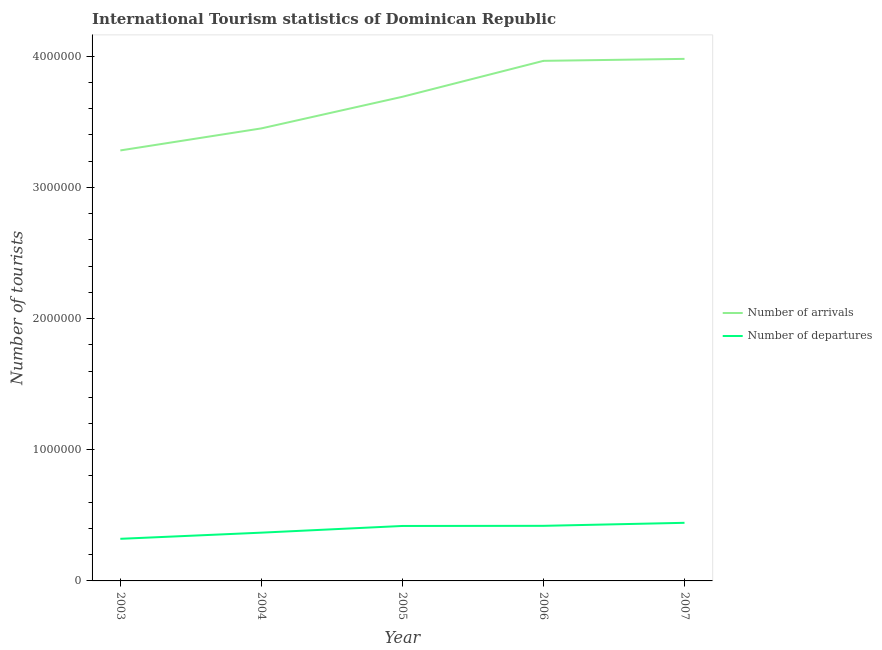How many different coloured lines are there?
Give a very brief answer. 2. Does the line corresponding to number of tourist departures intersect with the line corresponding to number of tourist arrivals?
Offer a very short reply. No. What is the number of tourist arrivals in 2007?
Your answer should be very brief. 3.98e+06. Across all years, what is the maximum number of tourist departures?
Give a very brief answer. 4.43e+05. Across all years, what is the minimum number of tourist arrivals?
Provide a succinct answer. 3.28e+06. In which year was the number of tourist arrivals maximum?
Provide a short and direct response. 2007. What is the total number of tourist departures in the graph?
Your response must be concise. 1.97e+06. What is the difference between the number of tourist departures in 2004 and that in 2007?
Give a very brief answer. -7.50e+04. What is the difference between the number of tourist departures in 2003 and the number of tourist arrivals in 2004?
Provide a succinct answer. -3.13e+06. What is the average number of tourist departures per year?
Ensure brevity in your answer.  3.94e+05. In the year 2007, what is the difference between the number of tourist departures and number of tourist arrivals?
Offer a very short reply. -3.54e+06. What is the ratio of the number of tourist departures in 2003 to that in 2004?
Ensure brevity in your answer.  0.87. Is the number of tourist arrivals in 2003 less than that in 2004?
Make the answer very short. Yes. Is the difference between the number of tourist departures in 2005 and 2007 greater than the difference between the number of tourist arrivals in 2005 and 2007?
Keep it short and to the point. Yes. What is the difference between the highest and the second highest number of tourist arrivals?
Make the answer very short. 1.50e+04. What is the difference between the highest and the lowest number of tourist departures?
Give a very brief answer. 1.22e+05. In how many years, is the number of tourist arrivals greater than the average number of tourist arrivals taken over all years?
Give a very brief answer. 3. What is the difference between two consecutive major ticks on the Y-axis?
Your answer should be compact. 1.00e+06. Are the values on the major ticks of Y-axis written in scientific E-notation?
Your answer should be very brief. No. What is the title of the graph?
Ensure brevity in your answer.  International Tourism statistics of Dominican Republic. Does "Residents" appear as one of the legend labels in the graph?
Offer a terse response. No. What is the label or title of the X-axis?
Your answer should be compact. Year. What is the label or title of the Y-axis?
Make the answer very short. Number of tourists. What is the Number of tourists in Number of arrivals in 2003?
Give a very brief answer. 3.28e+06. What is the Number of tourists in Number of departures in 2003?
Your answer should be compact. 3.21e+05. What is the Number of tourists of Number of arrivals in 2004?
Provide a short and direct response. 3.45e+06. What is the Number of tourists in Number of departures in 2004?
Offer a very short reply. 3.68e+05. What is the Number of tourists in Number of arrivals in 2005?
Keep it short and to the point. 3.69e+06. What is the Number of tourists in Number of departures in 2005?
Ensure brevity in your answer.  4.19e+05. What is the Number of tourists of Number of arrivals in 2006?
Your response must be concise. 3.96e+06. What is the Number of tourists of Number of departures in 2006?
Your answer should be compact. 4.20e+05. What is the Number of tourists in Number of arrivals in 2007?
Your answer should be compact. 3.98e+06. What is the Number of tourists in Number of departures in 2007?
Give a very brief answer. 4.43e+05. Across all years, what is the maximum Number of tourists in Number of arrivals?
Your answer should be very brief. 3.98e+06. Across all years, what is the maximum Number of tourists of Number of departures?
Provide a succinct answer. 4.43e+05. Across all years, what is the minimum Number of tourists of Number of arrivals?
Make the answer very short. 3.28e+06. Across all years, what is the minimum Number of tourists of Number of departures?
Keep it short and to the point. 3.21e+05. What is the total Number of tourists in Number of arrivals in the graph?
Provide a short and direct response. 1.84e+07. What is the total Number of tourists in Number of departures in the graph?
Give a very brief answer. 1.97e+06. What is the difference between the Number of tourists of Number of arrivals in 2003 and that in 2004?
Provide a short and direct response. -1.68e+05. What is the difference between the Number of tourists of Number of departures in 2003 and that in 2004?
Make the answer very short. -4.70e+04. What is the difference between the Number of tourists in Number of arrivals in 2003 and that in 2005?
Keep it short and to the point. -4.09e+05. What is the difference between the Number of tourists of Number of departures in 2003 and that in 2005?
Make the answer very short. -9.80e+04. What is the difference between the Number of tourists of Number of arrivals in 2003 and that in 2006?
Ensure brevity in your answer.  -6.83e+05. What is the difference between the Number of tourists in Number of departures in 2003 and that in 2006?
Make the answer very short. -9.90e+04. What is the difference between the Number of tourists of Number of arrivals in 2003 and that in 2007?
Your answer should be compact. -6.98e+05. What is the difference between the Number of tourists in Number of departures in 2003 and that in 2007?
Provide a short and direct response. -1.22e+05. What is the difference between the Number of tourists in Number of arrivals in 2004 and that in 2005?
Your response must be concise. -2.41e+05. What is the difference between the Number of tourists in Number of departures in 2004 and that in 2005?
Provide a short and direct response. -5.10e+04. What is the difference between the Number of tourists in Number of arrivals in 2004 and that in 2006?
Provide a succinct answer. -5.15e+05. What is the difference between the Number of tourists in Number of departures in 2004 and that in 2006?
Provide a succinct answer. -5.20e+04. What is the difference between the Number of tourists in Number of arrivals in 2004 and that in 2007?
Offer a terse response. -5.30e+05. What is the difference between the Number of tourists in Number of departures in 2004 and that in 2007?
Your answer should be very brief. -7.50e+04. What is the difference between the Number of tourists of Number of arrivals in 2005 and that in 2006?
Your answer should be compact. -2.74e+05. What is the difference between the Number of tourists in Number of departures in 2005 and that in 2006?
Your answer should be compact. -1000. What is the difference between the Number of tourists of Number of arrivals in 2005 and that in 2007?
Make the answer very short. -2.89e+05. What is the difference between the Number of tourists of Number of departures in 2005 and that in 2007?
Offer a terse response. -2.40e+04. What is the difference between the Number of tourists of Number of arrivals in 2006 and that in 2007?
Keep it short and to the point. -1.50e+04. What is the difference between the Number of tourists of Number of departures in 2006 and that in 2007?
Ensure brevity in your answer.  -2.30e+04. What is the difference between the Number of tourists of Number of arrivals in 2003 and the Number of tourists of Number of departures in 2004?
Provide a succinct answer. 2.91e+06. What is the difference between the Number of tourists in Number of arrivals in 2003 and the Number of tourists in Number of departures in 2005?
Offer a very short reply. 2.86e+06. What is the difference between the Number of tourists in Number of arrivals in 2003 and the Number of tourists in Number of departures in 2006?
Offer a very short reply. 2.86e+06. What is the difference between the Number of tourists of Number of arrivals in 2003 and the Number of tourists of Number of departures in 2007?
Give a very brief answer. 2.84e+06. What is the difference between the Number of tourists in Number of arrivals in 2004 and the Number of tourists in Number of departures in 2005?
Provide a succinct answer. 3.03e+06. What is the difference between the Number of tourists of Number of arrivals in 2004 and the Number of tourists of Number of departures in 2006?
Provide a succinct answer. 3.03e+06. What is the difference between the Number of tourists in Number of arrivals in 2004 and the Number of tourists in Number of departures in 2007?
Offer a very short reply. 3.01e+06. What is the difference between the Number of tourists of Number of arrivals in 2005 and the Number of tourists of Number of departures in 2006?
Offer a very short reply. 3.27e+06. What is the difference between the Number of tourists of Number of arrivals in 2005 and the Number of tourists of Number of departures in 2007?
Your response must be concise. 3.25e+06. What is the difference between the Number of tourists in Number of arrivals in 2006 and the Number of tourists in Number of departures in 2007?
Make the answer very short. 3.52e+06. What is the average Number of tourists of Number of arrivals per year?
Offer a terse response. 3.67e+06. What is the average Number of tourists of Number of departures per year?
Your answer should be compact. 3.94e+05. In the year 2003, what is the difference between the Number of tourists in Number of arrivals and Number of tourists in Number of departures?
Offer a very short reply. 2.96e+06. In the year 2004, what is the difference between the Number of tourists in Number of arrivals and Number of tourists in Number of departures?
Your answer should be compact. 3.08e+06. In the year 2005, what is the difference between the Number of tourists in Number of arrivals and Number of tourists in Number of departures?
Offer a terse response. 3.27e+06. In the year 2006, what is the difference between the Number of tourists of Number of arrivals and Number of tourists of Number of departures?
Provide a short and direct response. 3.54e+06. In the year 2007, what is the difference between the Number of tourists of Number of arrivals and Number of tourists of Number of departures?
Offer a very short reply. 3.54e+06. What is the ratio of the Number of tourists in Number of arrivals in 2003 to that in 2004?
Offer a very short reply. 0.95. What is the ratio of the Number of tourists in Number of departures in 2003 to that in 2004?
Offer a terse response. 0.87. What is the ratio of the Number of tourists of Number of arrivals in 2003 to that in 2005?
Your answer should be very brief. 0.89. What is the ratio of the Number of tourists in Number of departures in 2003 to that in 2005?
Make the answer very short. 0.77. What is the ratio of the Number of tourists in Number of arrivals in 2003 to that in 2006?
Ensure brevity in your answer.  0.83. What is the ratio of the Number of tourists in Number of departures in 2003 to that in 2006?
Provide a succinct answer. 0.76. What is the ratio of the Number of tourists in Number of arrivals in 2003 to that in 2007?
Offer a very short reply. 0.82. What is the ratio of the Number of tourists in Number of departures in 2003 to that in 2007?
Keep it short and to the point. 0.72. What is the ratio of the Number of tourists in Number of arrivals in 2004 to that in 2005?
Offer a very short reply. 0.93. What is the ratio of the Number of tourists in Number of departures in 2004 to that in 2005?
Provide a succinct answer. 0.88. What is the ratio of the Number of tourists of Number of arrivals in 2004 to that in 2006?
Provide a succinct answer. 0.87. What is the ratio of the Number of tourists in Number of departures in 2004 to that in 2006?
Your response must be concise. 0.88. What is the ratio of the Number of tourists of Number of arrivals in 2004 to that in 2007?
Give a very brief answer. 0.87. What is the ratio of the Number of tourists of Number of departures in 2004 to that in 2007?
Provide a succinct answer. 0.83. What is the ratio of the Number of tourists in Number of arrivals in 2005 to that in 2006?
Give a very brief answer. 0.93. What is the ratio of the Number of tourists in Number of arrivals in 2005 to that in 2007?
Give a very brief answer. 0.93. What is the ratio of the Number of tourists in Number of departures in 2005 to that in 2007?
Make the answer very short. 0.95. What is the ratio of the Number of tourists of Number of arrivals in 2006 to that in 2007?
Your response must be concise. 1. What is the ratio of the Number of tourists in Number of departures in 2006 to that in 2007?
Your response must be concise. 0.95. What is the difference between the highest and the second highest Number of tourists in Number of arrivals?
Provide a succinct answer. 1.50e+04. What is the difference between the highest and the second highest Number of tourists in Number of departures?
Give a very brief answer. 2.30e+04. What is the difference between the highest and the lowest Number of tourists of Number of arrivals?
Make the answer very short. 6.98e+05. What is the difference between the highest and the lowest Number of tourists of Number of departures?
Your answer should be compact. 1.22e+05. 